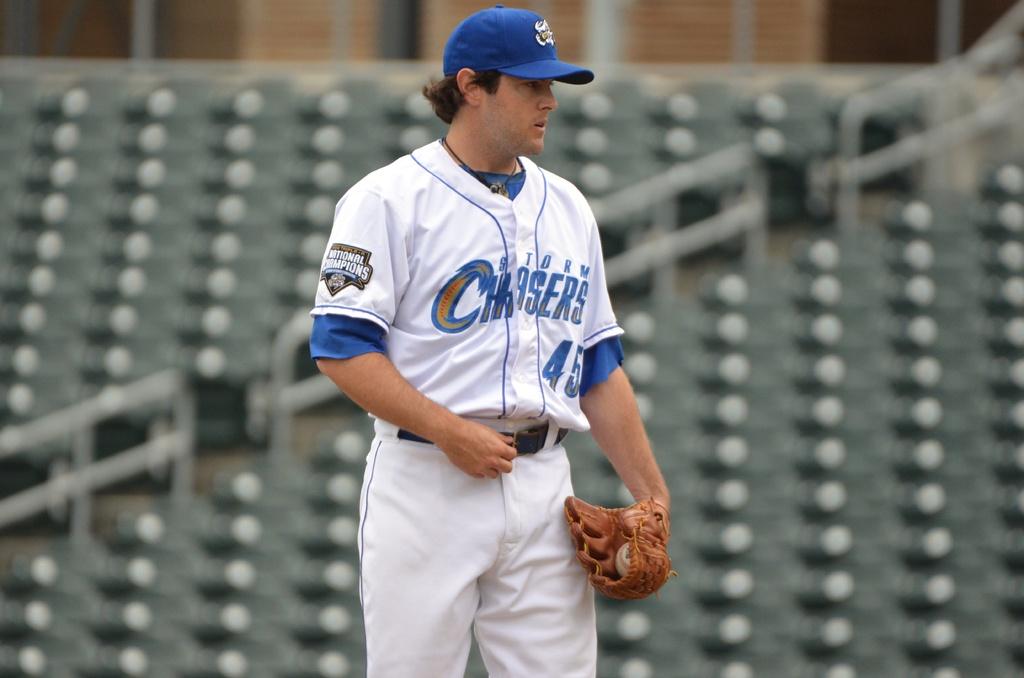What is the name of the team this baseball player plays for?
Your answer should be very brief. Storm chasers. What number is on the jersey?
Your response must be concise. 45. 